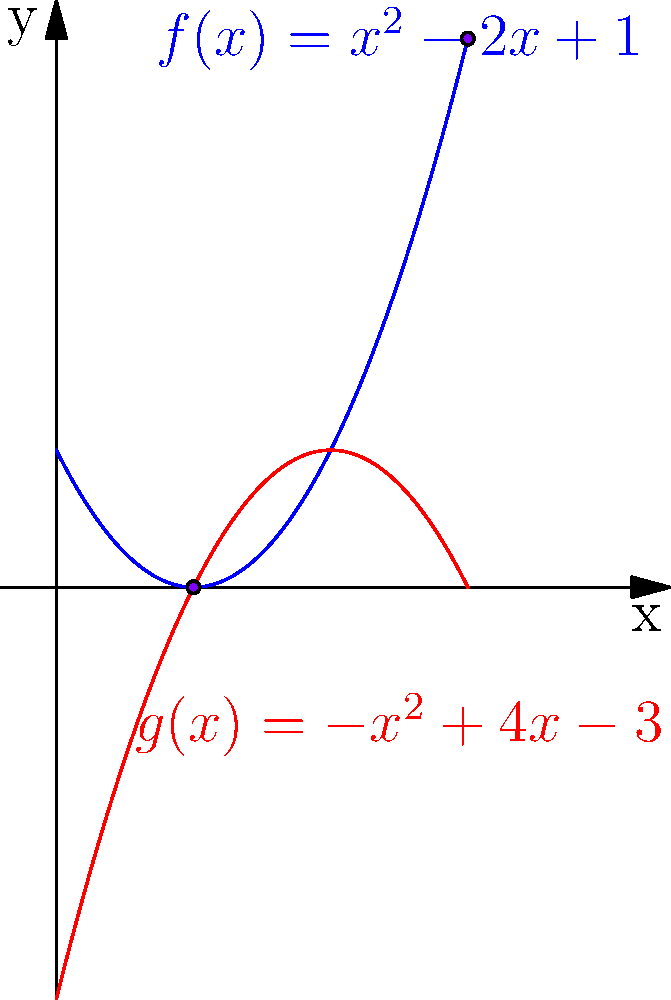Considere as funções polinomiais $f(x) = x^2 - 2x + 1$ e $g(x) = -x^2 + 4x - 3$. Determine os pontos de interseção das duas curvas e calcule a área da região limitada por elas. Otimize sua solução para eficiência computacional. Vamos resolver este problema passo a passo:

1) Para encontrar os pontos de interseção, igualamos as funções:
   $$x^2 - 2x + 1 = -x^2 + 4x - 3$$

2) Reorganizando:
   $$2x^2 - 6x + 4 = 0$$

3) Dividindo por 2:
   $$x^2 - 3x + 2 = 0$$

4) Usando a fórmula quadrática, $x = \frac{-b \pm \sqrt{b^2 - 4ac}}{2a}$:
   $$x = \frac{3 \pm \sqrt{9 - 8}}{2} = \frac{3 \pm 1}{2}$$

5) Portanto, os pontos de interseção são:
   $x_1 = 1$ e $x_2 = 2$

6) Para $x_1 = 1$: $f(1) = g(1) = 0$
   Para $x_2 = 2$: $f(2) = g(2) = 1$

7) Para calcular a área, integramos a diferença entre as funções:
   $$\text{Área} = \int_1^2 (g(x) - f(x)) dx$$

8) Simplificando:
   $$\int_1^2 ((-x^2 + 4x - 3) - (x^2 - 2x + 1)) dx$$
   $$= \int_1^2 (-2x^2 + 6x - 4) dx$$

9) Integrando:
   $$= \left[-\frac{2x^3}{3} + 3x^2 - 4x\right]_1^2$$

10) Calculando:
    $$= \left(-\frac{16}{3} + 12 - 8\right) - \left(-\frac{2}{3} + 3 - 4\right)$$
    $$= \left(-\frac{16}{3} + 4\right) - \left(-\frac{5}{3}\right) = -\frac{16}{3} + 4 + \frac{5}{3} = \frac{1}{3}$$

Para otimização, poderíamos usar métodos numéricos como a Regra de Simpson para aproximar a integral, o que seria mais eficiente para polinômios de grau superior.
Answer: $\frac{1}{3}$ 